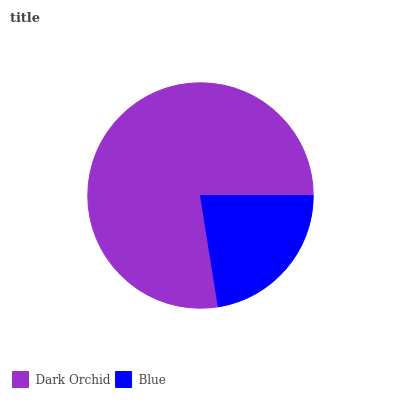Is Blue the minimum?
Answer yes or no. Yes. Is Dark Orchid the maximum?
Answer yes or no. Yes. Is Blue the maximum?
Answer yes or no. No. Is Dark Orchid greater than Blue?
Answer yes or no. Yes. Is Blue less than Dark Orchid?
Answer yes or no. Yes. Is Blue greater than Dark Orchid?
Answer yes or no. No. Is Dark Orchid less than Blue?
Answer yes or no. No. Is Dark Orchid the high median?
Answer yes or no. Yes. Is Blue the low median?
Answer yes or no. Yes. Is Blue the high median?
Answer yes or no. No. Is Dark Orchid the low median?
Answer yes or no. No. 